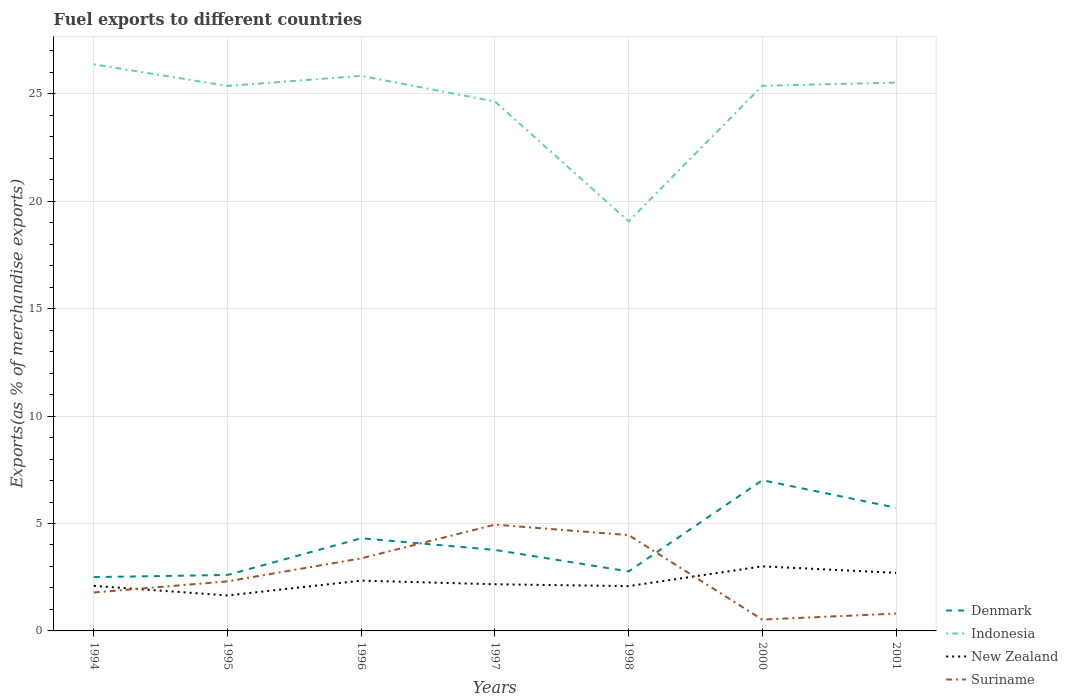How many different coloured lines are there?
Your response must be concise. 4. Is the number of lines equal to the number of legend labels?
Give a very brief answer. Yes. Across all years, what is the maximum percentage of exports to different countries in Suriname?
Offer a very short reply. 0.53. In which year was the percentage of exports to different countries in Indonesia maximum?
Your answer should be compact. 1998. What is the total percentage of exports to different countries in New Zealand in the graph?
Offer a very short reply. -0.66. What is the difference between the highest and the second highest percentage of exports to different countries in Denmark?
Keep it short and to the point. 4.51. What is the difference between the highest and the lowest percentage of exports to different countries in Denmark?
Make the answer very short. 3. How many years are there in the graph?
Offer a very short reply. 7. Are the values on the major ticks of Y-axis written in scientific E-notation?
Your answer should be compact. No. Does the graph contain any zero values?
Provide a short and direct response. No. Where does the legend appear in the graph?
Your answer should be very brief. Bottom right. How are the legend labels stacked?
Provide a succinct answer. Vertical. What is the title of the graph?
Your response must be concise. Fuel exports to different countries. What is the label or title of the X-axis?
Provide a short and direct response. Years. What is the label or title of the Y-axis?
Offer a terse response. Exports(as % of merchandise exports). What is the Exports(as % of merchandise exports) of Denmark in 1994?
Your answer should be compact. 2.5. What is the Exports(as % of merchandise exports) of Indonesia in 1994?
Make the answer very short. 26.37. What is the Exports(as % of merchandise exports) of New Zealand in 1994?
Give a very brief answer. 2.1. What is the Exports(as % of merchandise exports) in Suriname in 1994?
Ensure brevity in your answer.  1.79. What is the Exports(as % of merchandise exports) in Denmark in 1995?
Provide a short and direct response. 2.6. What is the Exports(as % of merchandise exports) of Indonesia in 1995?
Offer a terse response. 25.36. What is the Exports(as % of merchandise exports) of New Zealand in 1995?
Ensure brevity in your answer.  1.65. What is the Exports(as % of merchandise exports) of Suriname in 1995?
Provide a succinct answer. 2.31. What is the Exports(as % of merchandise exports) in Denmark in 1996?
Make the answer very short. 4.31. What is the Exports(as % of merchandise exports) of Indonesia in 1996?
Your answer should be very brief. 25.83. What is the Exports(as % of merchandise exports) of New Zealand in 1996?
Keep it short and to the point. 2.34. What is the Exports(as % of merchandise exports) in Suriname in 1996?
Keep it short and to the point. 3.38. What is the Exports(as % of merchandise exports) in Denmark in 1997?
Give a very brief answer. 3.77. What is the Exports(as % of merchandise exports) in Indonesia in 1997?
Ensure brevity in your answer.  24.64. What is the Exports(as % of merchandise exports) in New Zealand in 1997?
Make the answer very short. 2.17. What is the Exports(as % of merchandise exports) in Suriname in 1997?
Offer a terse response. 4.95. What is the Exports(as % of merchandise exports) in Denmark in 1998?
Your answer should be very brief. 2.77. What is the Exports(as % of merchandise exports) of Indonesia in 1998?
Give a very brief answer. 19.06. What is the Exports(as % of merchandise exports) in New Zealand in 1998?
Ensure brevity in your answer.  2.09. What is the Exports(as % of merchandise exports) of Suriname in 1998?
Your answer should be compact. 4.46. What is the Exports(as % of merchandise exports) in Denmark in 2000?
Give a very brief answer. 7.02. What is the Exports(as % of merchandise exports) in Indonesia in 2000?
Keep it short and to the point. 25.37. What is the Exports(as % of merchandise exports) of New Zealand in 2000?
Offer a terse response. 3. What is the Exports(as % of merchandise exports) of Suriname in 2000?
Your answer should be very brief. 0.53. What is the Exports(as % of merchandise exports) of Denmark in 2001?
Provide a succinct answer. 5.73. What is the Exports(as % of merchandise exports) in Indonesia in 2001?
Give a very brief answer. 25.52. What is the Exports(as % of merchandise exports) in New Zealand in 2001?
Keep it short and to the point. 2.7. What is the Exports(as % of merchandise exports) of Suriname in 2001?
Offer a terse response. 0.81. Across all years, what is the maximum Exports(as % of merchandise exports) of Denmark?
Keep it short and to the point. 7.02. Across all years, what is the maximum Exports(as % of merchandise exports) in Indonesia?
Provide a succinct answer. 26.37. Across all years, what is the maximum Exports(as % of merchandise exports) of New Zealand?
Your answer should be compact. 3. Across all years, what is the maximum Exports(as % of merchandise exports) of Suriname?
Your answer should be compact. 4.95. Across all years, what is the minimum Exports(as % of merchandise exports) of Denmark?
Your answer should be compact. 2.5. Across all years, what is the minimum Exports(as % of merchandise exports) in Indonesia?
Provide a short and direct response. 19.06. Across all years, what is the minimum Exports(as % of merchandise exports) of New Zealand?
Provide a short and direct response. 1.65. Across all years, what is the minimum Exports(as % of merchandise exports) in Suriname?
Provide a short and direct response. 0.53. What is the total Exports(as % of merchandise exports) of Denmark in the graph?
Give a very brief answer. 28.71. What is the total Exports(as % of merchandise exports) of Indonesia in the graph?
Give a very brief answer. 172.16. What is the total Exports(as % of merchandise exports) of New Zealand in the graph?
Provide a short and direct response. 16.05. What is the total Exports(as % of merchandise exports) of Suriname in the graph?
Make the answer very short. 18.21. What is the difference between the Exports(as % of merchandise exports) of Denmark in 1994 and that in 1995?
Give a very brief answer. -0.1. What is the difference between the Exports(as % of merchandise exports) in New Zealand in 1994 and that in 1995?
Ensure brevity in your answer.  0.44. What is the difference between the Exports(as % of merchandise exports) of Suriname in 1994 and that in 1995?
Provide a succinct answer. -0.52. What is the difference between the Exports(as % of merchandise exports) of Denmark in 1994 and that in 1996?
Offer a terse response. -1.81. What is the difference between the Exports(as % of merchandise exports) in Indonesia in 1994 and that in 1996?
Give a very brief answer. 0.54. What is the difference between the Exports(as % of merchandise exports) of New Zealand in 1994 and that in 1996?
Make the answer very short. -0.24. What is the difference between the Exports(as % of merchandise exports) in Suriname in 1994 and that in 1996?
Your answer should be compact. -1.59. What is the difference between the Exports(as % of merchandise exports) in Denmark in 1994 and that in 1997?
Keep it short and to the point. -1.27. What is the difference between the Exports(as % of merchandise exports) in Indonesia in 1994 and that in 1997?
Keep it short and to the point. 1.73. What is the difference between the Exports(as % of merchandise exports) of New Zealand in 1994 and that in 1997?
Make the answer very short. -0.08. What is the difference between the Exports(as % of merchandise exports) in Suriname in 1994 and that in 1997?
Provide a short and direct response. -3.16. What is the difference between the Exports(as % of merchandise exports) in Denmark in 1994 and that in 1998?
Ensure brevity in your answer.  -0.27. What is the difference between the Exports(as % of merchandise exports) in Indonesia in 1994 and that in 1998?
Give a very brief answer. 7.31. What is the difference between the Exports(as % of merchandise exports) of New Zealand in 1994 and that in 1998?
Offer a very short reply. 0.01. What is the difference between the Exports(as % of merchandise exports) in Suriname in 1994 and that in 1998?
Provide a short and direct response. -2.67. What is the difference between the Exports(as % of merchandise exports) in Denmark in 1994 and that in 2000?
Your answer should be compact. -4.51. What is the difference between the Exports(as % of merchandise exports) of Indonesia in 1994 and that in 2000?
Keep it short and to the point. 1. What is the difference between the Exports(as % of merchandise exports) in New Zealand in 1994 and that in 2000?
Keep it short and to the point. -0.91. What is the difference between the Exports(as % of merchandise exports) in Suriname in 1994 and that in 2000?
Your answer should be very brief. 1.26. What is the difference between the Exports(as % of merchandise exports) of Denmark in 1994 and that in 2001?
Provide a succinct answer. -3.23. What is the difference between the Exports(as % of merchandise exports) in Indonesia in 1994 and that in 2001?
Provide a short and direct response. 0.85. What is the difference between the Exports(as % of merchandise exports) of New Zealand in 1994 and that in 2001?
Your response must be concise. -0.61. What is the difference between the Exports(as % of merchandise exports) of Suriname in 1994 and that in 2001?
Your answer should be compact. 0.98. What is the difference between the Exports(as % of merchandise exports) of Denmark in 1995 and that in 1996?
Your answer should be very brief. -1.71. What is the difference between the Exports(as % of merchandise exports) in Indonesia in 1995 and that in 1996?
Your answer should be very brief. -0.47. What is the difference between the Exports(as % of merchandise exports) of New Zealand in 1995 and that in 1996?
Your answer should be compact. -0.69. What is the difference between the Exports(as % of merchandise exports) in Suriname in 1995 and that in 1996?
Offer a very short reply. -1.07. What is the difference between the Exports(as % of merchandise exports) in Denmark in 1995 and that in 1997?
Offer a terse response. -1.17. What is the difference between the Exports(as % of merchandise exports) in Indonesia in 1995 and that in 1997?
Keep it short and to the point. 0.72. What is the difference between the Exports(as % of merchandise exports) in New Zealand in 1995 and that in 1997?
Provide a short and direct response. -0.52. What is the difference between the Exports(as % of merchandise exports) of Suriname in 1995 and that in 1997?
Your answer should be very brief. -2.64. What is the difference between the Exports(as % of merchandise exports) of Denmark in 1995 and that in 1998?
Your response must be concise. -0.16. What is the difference between the Exports(as % of merchandise exports) in Indonesia in 1995 and that in 1998?
Your response must be concise. 6.3. What is the difference between the Exports(as % of merchandise exports) of New Zealand in 1995 and that in 1998?
Give a very brief answer. -0.43. What is the difference between the Exports(as % of merchandise exports) of Suriname in 1995 and that in 1998?
Keep it short and to the point. -2.15. What is the difference between the Exports(as % of merchandise exports) of Denmark in 1995 and that in 2000?
Keep it short and to the point. -4.41. What is the difference between the Exports(as % of merchandise exports) of Indonesia in 1995 and that in 2000?
Provide a succinct answer. -0.01. What is the difference between the Exports(as % of merchandise exports) in New Zealand in 1995 and that in 2000?
Ensure brevity in your answer.  -1.35. What is the difference between the Exports(as % of merchandise exports) of Suriname in 1995 and that in 2000?
Give a very brief answer. 1.78. What is the difference between the Exports(as % of merchandise exports) in Denmark in 1995 and that in 2001?
Keep it short and to the point. -3.13. What is the difference between the Exports(as % of merchandise exports) in Indonesia in 1995 and that in 2001?
Offer a terse response. -0.16. What is the difference between the Exports(as % of merchandise exports) of New Zealand in 1995 and that in 2001?
Provide a short and direct response. -1.05. What is the difference between the Exports(as % of merchandise exports) of Suriname in 1995 and that in 2001?
Make the answer very short. 1.5. What is the difference between the Exports(as % of merchandise exports) in Denmark in 1996 and that in 1997?
Ensure brevity in your answer.  0.54. What is the difference between the Exports(as % of merchandise exports) in Indonesia in 1996 and that in 1997?
Your response must be concise. 1.19. What is the difference between the Exports(as % of merchandise exports) in New Zealand in 1996 and that in 1997?
Offer a terse response. 0.17. What is the difference between the Exports(as % of merchandise exports) in Suriname in 1996 and that in 1997?
Provide a succinct answer. -1.57. What is the difference between the Exports(as % of merchandise exports) in Denmark in 1996 and that in 1998?
Provide a succinct answer. 1.54. What is the difference between the Exports(as % of merchandise exports) of Indonesia in 1996 and that in 1998?
Ensure brevity in your answer.  6.77. What is the difference between the Exports(as % of merchandise exports) in New Zealand in 1996 and that in 1998?
Provide a short and direct response. 0.25. What is the difference between the Exports(as % of merchandise exports) of Suriname in 1996 and that in 1998?
Offer a very short reply. -1.08. What is the difference between the Exports(as % of merchandise exports) of Denmark in 1996 and that in 2000?
Keep it short and to the point. -2.7. What is the difference between the Exports(as % of merchandise exports) of Indonesia in 1996 and that in 2000?
Provide a short and direct response. 0.46. What is the difference between the Exports(as % of merchandise exports) in New Zealand in 1996 and that in 2000?
Offer a terse response. -0.66. What is the difference between the Exports(as % of merchandise exports) of Suriname in 1996 and that in 2000?
Your response must be concise. 2.85. What is the difference between the Exports(as % of merchandise exports) of Denmark in 1996 and that in 2001?
Provide a short and direct response. -1.42. What is the difference between the Exports(as % of merchandise exports) of Indonesia in 1996 and that in 2001?
Offer a very short reply. 0.31. What is the difference between the Exports(as % of merchandise exports) of New Zealand in 1996 and that in 2001?
Ensure brevity in your answer.  -0.36. What is the difference between the Exports(as % of merchandise exports) in Suriname in 1996 and that in 2001?
Offer a terse response. 2.57. What is the difference between the Exports(as % of merchandise exports) in Denmark in 1997 and that in 1998?
Your answer should be very brief. 1. What is the difference between the Exports(as % of merchandise exports) in Indonesia in 1997 and that in 1998?
Give a very brief answer. 5.58. What is the difference between the Exports(as % of merchandise exports) of New Zealand in 1997 and that in 1998?
Offer a terse response. 0.09. What is the difference between the Exports(as % of merchandise exports) in Suriname in 1997 and that in 1998?
Your response must be concise. 0.49. What is the difference between the Exports(as % of merchandise exports) of Denmark in 1997 and that in 2000?
Offer a very short reply. -3.25. What is the difference between the Exports(as % of merchandise exports) in Indonesia in 1997 and that in 2000?
Keep it short and to the point. -0.73. What is the difference between the Exports(as % of merchandise exports) of New Zealand in 1997 and that in 2000?
Your answer should be compact. -0.83. What is the difference between the Exports(as % of merchandise exports) of Suriname in 1997 and that in 2000?
Give a very brief answer. 4.42. What is the difference between the Exports(as % of merchandise exports) in Denmark in 1997 and that in 2001?
Provide a short and direct response. -1.96. What is the difference between the Exports(as % of merchandise exports) in Indonesia in 1997 and that in 2001?
Provide a short and direct response. -0.88. What is the difference between the Exports(as % of merchandise exports) of New Zealand in 1997 and that in 2001?
Make the answer very short. -0.53. What is the difference between the Exports(as % of merchandise exports) in Suriname in 1997 and that in 2001?
Your response must be concise. 4.14. What is the difference between the Exports(as % of merchandise exports) of Denmark in 1998 and that in 2000?
Your answer should be very brief. -4.25. What is the difference between the Exports(as % of merchandise exports) of Indonesia in 1998 and that in 2000?
Your answer should be compact. -6.31. What is the difference between the Exports(as % of merchandise exports) in New Zealand in 1998 and that in 2000?
Make the answer very short. -0.92. What is the difference between the Exports(as % of merchandise exports) of Suriname in 1998 and that in 2000?
Offer a very short reply. 3.93. What is the difference between the Exports(as % of merchandise exports) in Denmark in 1998 and that in 2001?
Keep it short and to the point. -2.96. What is the difference between the Exports(as % of merchandise exports) of Indonesia in 1998 and that in 2001?
Your response must be concise. -6.46. What is the difference between the Exports(as % of merchandise exports) in New Zealand in 1998 and that in 2001?
Provide a short and direct response. -0.62. What is the difference between the Exports(as % of merchandise exports) of Suriname in 1998 and that in 2001?
Your response must be concise. 3.65. What is the difference between the Exports(as % of merchandise exports) of Denmark in 2000 and that in 2001?
Give a very brief answer. 1.28. What is the difference between the Exports(as % of merchandise exports) of Indonesia in 2000 and that in 2001?
Ensure brevity in your answer.  -0.15. What is the difference between the Exports(as % of merchandise exports) in New Zealand in 2000 and that in 2001?
Keep it short and to the point. 0.3. What is the difference between the Exports(as % of merchandise exports) in Suriname in 2000 and that in 2001?
Your response must be concise. -0.28. What is the difference between the Exports(as % of merchandise exports) of Denmark in 1994 and the Exports(as % of merchandise exports) of Indonesia in 1995?
Provide a succinct answer. -22.86. What is the difference between the Exports(as % of merchandise exports) of Denmark in 1994 and the Exports(as % of merchandise exports) of New Zealand in 1995?
Your answer should be very brief. 0.85. What is the difference between the Exports(as % of merchandise exports) of Denmark in 1994 and the Exports(as % of merchandise exports) of Suriname in 1995?
Make the answer very short. 0.2. What is the difference between the Exports(as % of merchandise exports) of Indonesia in 1994 and the Exports(as % of merchandise exports) of New Zealand in 1995?
Give a very brief answer. 24.72. What is the difference between the Exports(as % of merchandise exports) of Indonesia in 1994 and the Exports(as % of merchandise exports) of Suriname in 1995?
Your answer should be compact. 24.06. What is the difference between the Exports(as % of merchandise exports) of New Zealand in 1994 and the Exports(as % of merchandise exports) of Suriname in 1995?
Keep it short and to the point. -0.21. What is the difference between the Exports(as % of merchandise exports) of Denmark in 1994 and the Exports(as % of merchandise exports) of Indonesia in 1996?
Your response must be concise. -23.33. What is the difference between the Exports(as % of merchandise exports) in Denmark in 1994 and the Exports(as % of merchandise exports) in New Zealand in 1996?
Provide a short and direct response. 0.16. What is the difference between the Exports(as % of merchandise exports) in Denmark in 1994 and the Exports(as % of merchandise exports) in Suriname in 1996?
Make the answer very short. -0.87. What is the difference between the Exports(as % of merchandise exports) of Indonesia in 1994 and the Exports(as % of merchandise exports) of New Zealand in 1996?
Provide a short and direct response. 24.03. What is the difference between the Exports(as % of merchandise exports) in Indonesia in 1994 and the Exports(as % of merchandise exports) in Suriname in 1996?
Make the answer very short. 22.99. What is the difference between the Exports(as % of merchandise exports) in New Zealand in 1994 and the Exports(as % of merchandise exports) in Suriname in 1996?
Make the answer very short. -1.28. What is the difference between the Exports(as % of merchandise exports) in Denmark in 1994 and the Exports(as % of merchandise exports) in Indonesia in 1997?
Your response must be concise. -22.14. What is the difference between the Exports(as % of merchandise exports) in Denmark in 1994 and the Exports(as % of merchandise exports) in New Zealand in 1997?
Your answer should be compact. 0.33. What is the difference between the Exports(as % of merchandise exports) in Denmark in 1994 and the Exports(as % of merchandise exports) in Suriname in 1997?
Your answer should be compact. -2.44. What is the difference between the Exports(as % of merchandise exports) of Indonesia in 1994 and the Exports(as % of merchandise exports) of New Zealand in 1997?
Offer a terse response. 24.2. What is the difference between the Exports(as % of merchandise exports) in Indonesia in 1994 and the Exports(as % of merchandise exports) in Suriname in 1997?
Offer a terse response. 21.42. What is the difference between the Exports(as % of merchandise exports) in New Zealand in 1994 and the Exports(as % of merchandise exports) in Suriname in 1997?
Your response must be concise. -2.85. What is the difference between the Exports(as % of merchandise exports) in Denmark in 1994 and the Exports(as % of merchandise exports) in Indonesia in 1998?
Your answer should be very brief. -16.56. What is the difference between the Exports(as % of merchandise exports) in Denmark in 1994 and the Exports(as % of merchandise exports) in New Zealand in 1998?
Provide a short and direct response. 0.42. What is the difference between the Exports(as % of merchandise exports) in Denmark in 1994 and the Exports(as % of merchandise exports) in Suriname in 1998?
Give a very brief answer. -1.96. What is the difference between the Exports(as % of merchandise exports) of Indonesia in 1994 and the Exports(as % of merchandise exports) of New Zealand in 1998?
Give a very brief answer. 24.28. What is the difference between the Exports(as % of merchandise exports) in Indonesia in 1994 and the Exports(as % of merchandise exports) in Suriname in 1998?
Your response must be concise. 21.91. What is the difference between the Exports(as % of merchandise exports) in New Zealand in 1994 and the Exports(as % of merchandise exports) in Suriname in 1998?
Your answer should be compact. -2.36. What is the difference between the Exports(as % of merchandise exports) in Denmark in 1994 and the Exports(as % of merchandise exports) in Indonesia in 2000?
Provide a short and direct response. -22.87. What is the difference between the Exports(as % of merchandise exports) in Denmark in 1994 and the Exports(as % of merchandise exports) in New Zealand in 2000?
Ensure brevity in your answer.  -0.5. What is the difference between the Exports(as % of merchandise exports) of Denmark in 1994 and the Exports(as % of merchandise exports) of Suriname in 2000?
Make the answer very short. 1.98. What is the difference between the Exports(as % of merchandise exports) of Indonesia in 1994 and the Exports(as % of merchandise exports) of New Zealand in 2000?
Offer a terse response. 23.36. What is the difference between the Exports(as % of merchandise exports) in Indonesia in 1994 and the Exports(as % of merchandise exports) in Suriname in 2000?
Give a very brief answer. 25.84. What is the difference between the Exports(as % of merchandise exports) in New Zealand in 1994 and the Exports(as % of merchandise exports) in Suriname in 2000?
Make the answer very short. 1.57. What is the difference between the Exports(as % of merchandise exports) of Denmark in 1994 and the Exports(as % of merchandise exports) of Indonesia in 2001?
Offer a very short reply. -23.02. What is the difference between the Exports(as % of merchandise exports) in Denmark in 1994 and the Exports(as % of merchandise exports) in New Zealand in 2001?
Your response must be concise. -0.2. What is the difference between the Exports(as % of merchandise exports) of Denmark in 1994 and the Exports(as % of merchandise exports) of Suriname in 2001?
Keep it short and to the point. 1.7. What is the difference between the Exports(as % of merchandise exports) in Indonesia in 1994 and the Exports(as % of merchandise exports) in New Zealand in 2001?
Ensure brevity in your answer.  23.67. What is the difference between the Exports(as % of merchandise exports) of Indonesia in 1994 and the Exports(as % of merchandise exports) of Suriname in 2001?
Your answer should be compact. 25.56. What is the difference between the Exports(as % of merchandise exports) in New Zealand in 1994 and the Exports(as % of merchandise exports) in Suriname in 2001?
Provide a short and direct response. 1.29. What is the difference between the Exports(as % of merchandise exports) in Denmark in 1995 and the Exports(as % of merchandise exports) in Indonesia in 1996?
Your answer should be compact. -23.23. What is the difference between the Exports(as % of merchandise exports) in Denmark in 1995 and the Exports(as % of merchandise exports) in New Zealand in 1996?
Your answer should be very brief. 0.26. What is the difference between the Exports(as % of merchandise exports) of Denmark in 1995 and the Exports(as % of merchandise exports) of Suriname in 1996?
Your response must be concise. -0.77. What is the difference between the Exports(as % of merchandise exports) of Indonesia in 1995 and the Exports(as % of merchandise exports) of New Zealand in 1996?
Make the answer very short. 23.02. What is the difference between the Exports(as % of merchandise exports) in Indonesia in 1995 and the Exports(as % of merchandise exports) in Suriname in 1996?
Provide a short and direct response. 21.99. What is the difference between the Exports(as % of merchandise exports) in New Zealand in 1995 and the Exports(as % of merchandise exports) in Suriname in 1996?
Make the answer very short. -1.73. What is the difference between the Exports(as % of merchandise exports) in Denmark in 1995 and the Exports(as % of merchandise exports) in Indonesia in 1997?
Keep it short and to the point. -22.04. What is the difference between the Exports(as % of merchandise exports) of Denmark in 1995 and the Exports(as % of merchandise exports) of New Zealand in 1997?
Keep it short and to the point. 0.43. What is the difference between the Exports(as % of merchandise exports) in Denmark in 1995 and the Exports(as % of merchandise exports) in Suriname in 1997?
Give a very brief answer. -2.34. What is the difference between the Exports(as % of merchandise exports) in Indonesia in 1995 and the Exports(as % of merchandise exports) in New Zealand in 1997?
Give a very brief answer. 23.19. What is the difference between the Exports(as % of merchandise exports) of Indonesia in 1995 and the Exports(as % of merchandise exports) of Suriname in 1997?
Offer a terse response. 20.42. What is the difference between the Exports(as % of merchandise exports) of New Zealand in 1995 and the Exports(as % of merchandise exports) of Suriname in 1997?
Offer a terse response. -3.29. What is the difference between the Exports(as % of merchandise exports) of Denmark in 1995 and the Exports(as % of merchandise exports) of Indonesia in 1998?
Offer a terse response. -16.46. What is the difference between the Exports(as % of merchandise exports) in Denmark in 1995 and the Exports(as % of merchandise exports) in New Zealand in 1998?
Your answer should be very brief. 0.52. What is the difference between the Exports(as % of merchandise exports) in Denmark in 1995 and the Exports(as % of merchandise exports) in Suriname in 1998?
Your answer should be very brief. -1.85. What is the difference between the Exports(as % of merchandise exports) of Indonesia in 1995 and the Exports(as % of merchandise exports) of New Zealand in 1998?
Offer a terse response. 23.28. What is the difference between the Exports(as % of merchandise exports) of Indonesia in 1995 and the Exports(as % of merchandise exports) of Suriname in 1998?
Offer a very short reply. 20.9. What is the difference between the Exports(as % of merchandise exports) of New Zealand in 1995 and the Exports(as % of merchandise exports) of Suriname in 1998?
Offer a very short reply. -2.81. What is the difference between the Exports(as % of merchandise exports) of Denmark in 1995 and the Exports(as % of merchandise exports) of Indonesia in 2000?
Offer a terse response. -22.77. What is the difference between the Exports(as % of merchandise exports) in Denmark in 1995 and the Exports(as % of merchandise exports) in New Zealand in 2000?
Give a very brief answer. -0.4. What is the difference between the Exports(as % of merchandise exports) of Denmark in 1995 and the Exports(as % of merchandise exports) of Suriname in 2000?
Ensure brevity in your answer.  2.08. What is the difference between the Exports(as % of merchandise exports) of Indonesia in 1995 and the Exports(as % of merchandise exports) of New Zealand in 2000?
Give a very brief answer. 22.36. What is the difference between the Exports(as % of merchandise exports) of Indonesia in 1995 and the Exports(as % of merchandise exports) of Suriname in 2000?
Make the answer very short. 24.84. What is the difference between the Exports(as % of merchandise exports) in New Zealand in 1995 and the Exports(as % of merchandise exports) in Suriname in 2000?
Keep it short and to the point. 1.12. What is the difference between the Exports(as % of merchandise exports) in Denmark in 1995 and the Exports(as % of merchandise exports) in Indonesia in 2001?
Your response must be concise. -22.92. What is the difference between the Exports(as % of merchandise exports) in Denmark in 1995 and the Exports(as % of merchandise exports) in New Zealand in 2001?
Ensure brevity in your answer.  -0.1. What is the difference between the Exports(as % of merchandise exports) in Denmark in 1995 and the Exports(as % of merchandise exports) in Suriname in 2001?
Give a very brief answer. 1.8. What is the difference between the Exports(as % of merchandise exports) in Indonesia in 1995 and the Exports(as % of merchandise exports) in New Zealand in 2001?
Your answer should be very brief. 22.66. What is the difference between the Exports(as % of merchandise exports) in Indonesia in 1995 and the Exports(as % of merchandise exports) in Suriname in 2001?
Your answer should be very brief. 24.56. What is the difference between the Exports(as % of merchandise exports) in New Zealand in 1995 and the Exports(as % of merchandise exports) in Suriname in 2001?
Offer a very short reply. 0.84. What is the difference between the Exports(as % of merchandise exports) in Denmark in 1996 and the Exports(as % of merchandise exports) in Indonesia in 1997?
Ensure brevity in your answer.  -20.33. What is the difference between the Exports(as % of merchandise exports) in Denmark in 1996 and the Exports(as % of merchandise exports) in New Zealand in 1997?
Keep it short and to the point. 2.14. What is the difference between the Exports(as % of merchandise exports) of Denmark in 1996 and the Exports(as % of merchandise exports) of Suriname in 1997?
Offer a very short reply. -0.63. What is the difference between the Exports(as % of merchandise exports) in Indonesia in 1996 and the Exports(as % of merchandise exports) in New Zealand in 1997?
Ensure brevity in your answer.  23.66. What is the difference between the Exports(as % of merchandise exports) of Indonesia in 1996 and the Exports(as % of merchandise exports) of Suriname in 1997?
Ensure brevity in your answer.  20.89. What is the difference between the Exports(as % of merchandise exports) of New Zealand in 1996 and the Exports(as % of merchandise exports) of Suriname in 1997?
Your response must be concise. -2.61. What is the difference between the Exports(as % of merchandise exports) in Denmark in 1996 and the Exports(as % of merchandise exports) in Indonesia in 1998?
Keep it short and to the point. -14.75. What is the difference between the Exports(as % of merchandise exports) of Denmark in 1996 and the Exports(as % of merchandise exports) of New Zealand in 1998?
Ensure brevity in your answer.  2.23. What is the difference between the Exports(as % of merchandise exports) in Denmark in 1996 and the Exports(as % of merchandise exports) in Suriname in 1998?
Your answer should be very brief. -0.15. What is the difference between the Exports(as % of merchandise exports) in Indonesia in 1996 and the Exports(as % of merchandise exports) in New Zealand in 1998?
Give a very brief answer. 23.75. What is the difference between the Exports(as % of merchandise exports) of Indonesia in 1996 and the Exports(as % of merchandise exports) of Suriname in 1998?
Your answer should be compact. 21.37. What is the difference between the Exports(as % of merchandise exports) in New Zealand in 1996 and the Exports(as % of merchandise exports) in Suriname in 1998?
Offer a terse response. -2.12. What is the difference between the Exports(as % of merchandise exports) in Denmark in 1996 and the Exports(as % of merchandise exports) in Indonesia in 2000?
Make the answer very short. -21.06. What is the difference between the Exports(as % of merchandise exports) in Denmark in 1996 and the Exports(as % of merchandise exports) in New Zealand in 2000?
Offer a very short reply. 1.31. What is the difference between the Exports(as % of merchandise exports) of Denmark in 1996 and the Exports(as % of merchandise exports) of Suriname in 2000?
Provide a succinct answer. 3.78. What is the difference between the Exports(as % of merchandise exports) in Indonesia in 1996 and the Exports(as % of merchandise exports) in New Zealand in 2000?
Offer a very short reply. 22.83. What is the difference between the Exports(as % of merchandise exports) of Indonesia in 1996 and the Exports(as % of merchandise exports) of Suriname in 2000?
Keep it short and to the point. 25.3. What is the difference between the Exports(as % of merchandise exports) in New Zealand in 1996 and the Exports(as % of merchandise exports) in Suriname in 2000?
Offer a very short reply. 1.81. What is the difference between the Exports(as % of merchandise exports) of Denmark in 1996 and the Exports(as % of merchandise exports) of Indonesia in 2001?
Offer a very short reply. -21.21. What is the difference between the Exports(as % of merchandise exports) in Denmark in 1996 and the Exports(as % of merchandise exports) in New Zealand in 2001?
Provide a short and direct response. 1.61. What is the difference between the Exports(as % of merchandise exports) in Denmark in 1996 and the Exports(as % of merchandise exports) in Suriname in 2001?
Make the answer very short. 3.51. What is the difference between the Exports(as % of merchandise exports) in Indonesia in 1996 and the Exports(as % of merchandise exports) in New Zealand in 2001?
Ensure brevity in your answer.  23.13. What is the difference between the Exports(as % of merchandise exports) of Indonesia in 1996 and the Exports(as % of merchandise exports) of Suriname in 2001?
Your answer should be compact. 25.03. What is the difference between the Exports(as % of merchandise exports) in New Zealand in 1996 and the Exports(as % of merchandise exports) in Suriname in 2001?
Your response must be concise. 1.53. What is the difference between the Exports(as % of merchandise exports) of Denmark in 1997 and the Exports(as % of merchandise exports) of Indonesia in 1998?
Offer a very short reply. -15.29. What is the difference between the Exports(as % of merchandise exports) in Denmark in 1997 and the Exports(as % of merchandise exports) in New Zealand in 1998?
Ensure brevity in your answer.  1.68. What is the difference between the Exports(as % of merchandise exports) of Denmark in 1997 and the Exports(as % of merchandise exports) of Suriname in 1998?
Provide a short and direct response. -0.69. What is the difference between the Exports(as % of merchandise exports) in Indonesia in 1997 and the Exports(as % of merchandise exports) in New Zealand in 1998?
Keep it short and to the point. 22.56. What is the difference between the Exports(as % of merchandise exports) of Indonesia in 1997 and the Exports(as % of merchandise exports) of Suriname in 1998?
Offer a terse response. 20.18. What is the difference between the Exports(as % of merchandise exports) in New Zealand in 1997 and the Exports(as % of merchandise exports) in Suriname in 1998?
Provide a short and direct response. -2.29. What is the difference between the Exports(as % of merchandise exports) of Denmark in 1997 and the Exports(as % of merchandise exports) of Indonesia in 2000?
Your answer should be compact. -21.6. What is the difference between the Exports(as % of merchandise exports) in Denmark in 1997 and the Exports(as % of merchandise exports) in New Zealand in 2000?
Your answer should be compact. 0.77. What is the difference between the Exports(as % of merchandise exports) of Denmark in 1997 and the Exports(as % of merchandise exports) of Suriname in 2000?
Your answer should be compact. 3.24. What is the difference between the Exports(as % of merchandise exports) in Indonesia in 1997 and the Exports(as % of merchandise exports) in New Zealand in 2000?
Ensure brevity in your answer.  21.64. What is the difference between the Exports(as % of merchandise exports) in Indonesia in 1997 and the Exports(as % of merchandise exports) in Suriname in 2000?
Keep it short and to the point. 24.11. What is the difference between the Exports(as % of merchandise exports) of New Zealand in 1997 and the Exports(as % of merchandise exports) of Suriname in 2000?
Your response must be concise. 1.64. What is the difference between the Exports(as % of merchandise exports) in Denmark in 1997 and the Exports(as % of merchandise exports) in Indonesia in 2001?
Provide a succinct answer. -21.75. What is the difference between the Exports(as % of merchandise exports) in Denmark in 1997 and the Exports(as % of merchandise exports) in New Zealand in 2001?
Your response must be concise. 1.07. What is the difference between the Exports(as % of merchandise exports) in Denmark in 1997 and the Exports(as % of merchandise exports) in Suriname in 2001?
Make the answer very short. 2.96. What is the difference between the Exports(as % of merchandise exports) of Indonesia in 1997 and the Exports(as % of merchandise exports) of New Zealand in 2001?
Provide a short and direct response. 21.94. What is the difference between the Exports(as % of merchandise exports) of Indonesia in 1997 and the Exports(as % of merchandise exports) of Suriname in 2001?
Your response must be concise. 23.83. What is the difference between the Exports(as % of merchandise exports) of New Zealand in 1997 and the Exports(as % of merchandise exports) of Suriname in 2001?
Your response must be concise. 1.37. What is the difference between the Exports(as % of merchandise exports) of Denmark in 1998 and the Exports(as % of merchandise exports) of Indonesia in 2000?
Provide a short and direct response. -22.6. What is the difference between the Exports(as % of merchandise exports) in Denmark in 1998 and the Exports(as % of merchandise exports) in New Zealand in 2000?
Provide a short and direct response. -0.24. What is the difference between the Exports(as % of merchandise exports) in Denmark in 1998 and the Exports(as % of merchandise exports) in Suriname in 2000?
Make the answer very short. 2.24. What is the difference between the Exports(as % of merchandise exports) in Indonesia in 1998 and the Exports(as % of merchandise exports) in New Zealand in 2000?
Offer a very short reply. 16.06. What is the difference between the Exports(as % of merchandise exports) in Indonesia in 1998 and the Exports(as % of merchandise exports) in Suriname in 2000?
Keep it short and to the point. 18.54. What is the difference between the Exports(as % of merchandise exports) of New Zealand in 1998 and the Exports(as % of merchandise exports) of Suriname in 2000?
Provide a short and direct response. 1.56. What is the difference between the Exports(as % of merchandise exports) in Denmark in 1998 and the Exports(as % of merchandise exports) in Indonesia in 2001?
Your answer should be compact. -22.75. What is the difference between the Exports(as % of merchandise exports) in Denmark in 1998 and the Exports(as % of merchandise exports) in New Zealand in 2001?
Provide a succinct answer. 0.07. What is the difference between the Exports(as % of merchandise exports) in Denmark in 1998 and the Exports(as % of merchandise exports) in Suriname in 2001?
Ensure brevity in your answer.  1.96. What is the difference between the Exports(as % of merchandise exports) of Indonesia in 1998 and the Exports(as % of merchandise exports) of New Zealand in 2001?
Provide a short and direct response. 16.36. What is the difference between the Exports(as % of merchandise exports) in Indonesia in 1998 and the Exports(as % of merchandise exports) in Suriname in 2001?
Provide a succinct answer. 18.26. What is the difference between the Exports(as % of merchandise exports) in New Zealand in 1998 and the Exports(as % of merchandise exports) in Suriname in 2001?
Provide a short and direct response. 1.28. What is the difference between the Exports(as % of merchandise exports) in Denmark in 2000 and the Exports(as % of merchandise exports) in Indonesia in 2001?
Provide a succinct answer. -18.5. What is the difference between the Exports(as % of merchandise exports) of Denmark in 2000 and the Exports(as % of merchandise exports) of New Zealand in 2001?
Give a very brief answer. 4.31. What is the difference between the Exports(as % of merchandise exports) of Denmark in 2000 and the Exports(as % of merchandise exports) of Suriname in 2001?
Your response must be concise. 6.21. What is the difference between the Exports(as % of merchandise exports) of Indonesia in 2000 and the Exports(as % of merchandise exports) of New Zealand in 2001?
Provide a succinct answer. 22.67. What is the difference between the Exports(as % of merchandise exports) in Indonesia in 2000 and the Exports(as % of merchandise exports) in Suriname in 2001?
Your answer should be compact. 24.56. What is the difference between the Exports(as % of merchandise exports) of New Zealand in 2000 and the Exports(as % of merchandise exports) of Suriname in 2001?
Make the answer very short. 2.2. What is the average Exports(as % of merchandise exports) in Denmark per year?
Keep it short and to the point. 4.1. What is the average Exports(as % of merchandise exports) in Indonesia per year?
Keep it short and to the point. 24.59. What is the average Exports(as % of merchandise exports) in New Zealand per year?
Your answer should be compact. 2.29. What is the average Exports(as % of merchandise exports) in Suriname per year?
Make the answer very short. 2.6. In the year 1994, what is the difference between the Exports(as % of merchandise exports) of Denmark and Exports(as % of merchandise exports) of Indonesia?
Keep it short and to the point. -23.87. In the year 1994, what is the difference between the Exports(as % of merchandise exports) in Denmark and Exports(as % of merchandise exports) in New Zealand?
Your answer should be very brief. 0.41. In the year 1994, what is the difference between the Exports(as % of merchandise exports) in Denmark and Exports(as % of merchandise exports) in Suriname?
Provide a short and direct response. 0.71. In the year 1994, what is the difference between the Exports(as % of merchandise exports) in Indonesia and Exports(as % of merchandise exports) in New Zealand?
Make the answer very short. 24.27. In the year 1994, what is the difference between the Exports(as % of merchandise exports) in Indonesia and Exports(as % of merchandise exports) in Suriname?
Keep it short and to the point. 24.58. In the year 1994, what is the difference between the Exports(as % of merchandise exports) in New Zealand and Exports(as % of merchandise exports) in Suriname?
Keep it short and to the point. 0.31. In the year 1995, what is the difference between the Exports(as % of merchandise exports) of Denmark and Exports(as % of merchandise exports) of Indonesia?
Make the answer very short. -22.76. In the year 1995, what is the difference between the Exports(as % of merchandise exports) in Denmark and Exports(as % of merchandise exports) in New Zealand?
Make the answer very short. 0.95. In the year 1995, what is the difference between the Exports(as % of merchandise exports) of Denmark and Exports(as % of merchandise exports) of Suriname?
Give a very brief answer. 0.3. In the year 1995, what is the difference between the Exports(as % of merchandise exports) of Indonesia and Exports(as % of merchandise exports) of New Zealand?
Your answer should be compact. 23.71. In the year 1995, what is the difference between the Exports(as % of merchandise exports) of Indonesia and Exports(as % of merchandise exports) of Suriname?
Make the answer very short. 23.06. In the year 1995, what is the difference between the Exports(as % of merchandise exports) of New Zealand and Exports(as % of merchandise exports) of Suriname?
Make the answer very short. -0.65. In the year 1996, what is the difference between the Exports(as % of merchandise exports) in Denmark and Exports(as % of merchandise exports) in Indonesia?
Give a very brief answer. -21.52. In the year 1996, what is the difference between the Exports(as % of merchandise exports) of Denmark and Exports(as % of merchandise exports) of New Zealand?
Offer a terse response. 1.97. In the year 1996, what is the difference between the Exports(as % of merchandise exports) of Denmark and Exports(as % of merchandise exports) of Suriname?
Provide a short and direct response. 0.94. In the year 1996, what is the difference between the Exports(as % of merchandise exports) of Indonesia and Exports(as % of merchandise exports) of New Zealand?
Give a very brief answer. 23.49. In the year 1996, what is the difference between the Exports(as % of merchandise exports) of Indonesia and Exports(as % of merchandise exports) of Suriname?
Your answer should be compact. 22.45. In the year 1996, what is the difference between the Exports(as % of merchandise exports) in New Zealand and Exports(as % of merchandise exports) in Suriname?
Provide a succinct answer. -1.04. In the year 1997, what is the difference between the Exports(as % of merchandise exports) of Denmark and Exports(as % of merchandise exports) of Indonesia?
Offer a terse response. -20.87. In the year 1997, what is the difference between the Exports(as % of merchandise exports) in Denmark and Exports(as % of merchandise exports) in New Zealand?
Your answer should be very brief. 1.6. In the year 1997, what is the difference between the Exports(as % of merchandise exports) in Denmark and Exports(as % of merchandise exports) in Suriname?
Offer a very short reply. -1.18. In the year 1997, what is the difference between the Exports(as % of merchandise exports) in Indonesia and Exports(as % of merchandise exports) in New Zealand?
Your response must be concise. 22.47. In the year 1997, what is the difference between the Exports(as % of merchandise exports) in Indonesia and Exports(as % of merchandise exports) in Suriname?
Provide a short and direct response. 19.69. In the year 1997, what is the difference between the Exports(as % of merchandise exports) of New Zealand and Exports(as % of merchandise exports) of Suriname?
Your answer should be compact. -2.77. In the year 1998, what is the difference between the Exports(as % of merchandise exports) of Denmark and Exports(as % of merchandise exports) of Indonesia?
Give a very brief answer. -16.3. In the year 1998, what is the difference between the Exports(as % of merchandise exports) in Denmark and Exports(as % of merchandise exports) in New Zealand?
Make the answer very short. 0.68. In the year 1998, what is the difference between the Exports(as % of merchandise exports) of Denmark and Exports(as % of merchandise exports) of Suriname?
Ensure brevity in your answer.  -1.69. In the year 1998, what is the difference between the Exports(as % of merchandise exports) in Indonesia and Exports(as % of merchandise exports) in New Zealand?
Provide a short and direct response. 16.98. In the year 1998, what is the difference between the Exports(as % of merchandise exports) of Indonesia and Exports(as % of merchandise exports) of Suriname?
Keep it short and to the point. 14.61. In the year 1998, what is the difference between the Exports(as % of merchandise exports) of New Zealand and Exports(as % of merchandise exports) of Suriname?
Your response must be concise. -2.37. In the year 2000, what is the difference between the Exports(as % of merchandise exports) of Denmark and Exports(as % of merchandise exports) of Indonesia?
Your response must be concise. -18.36. In the year 2000, what is the difference between the Exports(as % of merchandise exports) of Denmark and Exports(as % of merchandise exports) of New Zealand?
Offer a terse response. 4.01. In the year 2000, what is the difference between the Exports(as % of merchandise exports) in Denmark and Exports(as % of merchandise exports) in Suriname?
Offer a very short reply. 6.49. In the year 2000, what is the difference between the Exports(as % of merchandise exports) of Indonesia and Exports(as % of merchandise exports) of New Zealand?
Provide a succinct answer. 22.37. In the year 2000, what is the difference between the Exports(as % of merchandise exports) of Indonesia and Exports(as % of merchandise exports) of Suriname?
Offer a terse response. 24.84. In the year 2000, what is the difference between the Exports(as % of merchandise exports) in New Zealand and Exports(as % of merchandise exports) in Suriname?
Your answer should be compact. 2.48. In the year 2001, what is the difference between the Exports(as % of merchandise exports) in Denmark and Exports(as % of merchandise exports) in Indonesia?
Your response must be concise. -19.79. In the year 2001, what is the difference between the Exports(as % of merchandise exports) of Denmark and Exports(as % of merchandise exports) of New Zealand?
Provide a short and direct response. 3.03. In the year 2001, what is the difference between the Exports(as % of merchandise exports) in Denmark and Exports(as % of merchandise exports) in Suriname?
Give a very brief answer. 4.93. In the year 2001, what is the difference between the Exports(as % of merchandise exports) of Indonesia and Exports(as % of merchandise exports) of New Zealand?
Make the answer very short. 22.82. In the year 2001, what is the difference between the Exports(as % of merchandise exports) in Indonesia and Exports(as % of merchandise exports) in Suriname?
Your answer should be very brief. 24.71. In the year 2001, what is the difference between the Exports(as % of merchandise exports) in New Zealand and Exports(as % of merchandise exports) in Suriname?
Give a very brief answer. 1.9. What is the ratio of the Exports(as % of merchandise exports) in Denmark in 1994 to that in 1995?
Give a very brief answer. 0.96. What is the ratio of the Exports(as % of merchandise exports) in Indonesia in 1994 to that in 1995?
Offer a terse response. 1.04. What is the ratio of the Exports(as % of merchandise exports) of New Zealand in 1994 to that in 1995?
Your response must be concise. 1.27. What is the ratio of the Exports(as % of merchandise exports) of Suriname in 1994 to that in 1995?
Give a very brief answer. 0.78. What is the ratio of the Exports(as % of merchandise exports) in Denmark in 1994 to that in 1996?
Offer a very short reply. 0.58. What is the ratio of the Exports(as % of merchandise exports) in Indonesia in 1994 to that in 1996?
Your response must be concise. 1.02. What is the ratio of the Exports(as % of merchandise exports) in New Zealand in 1994 to that in 1996?
Your response must be concise. 0.9. What is the ratio of the Exports(as % of merchandise exports) of Suriname in 1994 to that in 1996?
Provide a short and direct response. 0.53. What is the ratio of the Exports(as % of merchandise exports) in Denmark in 1994 to that in 1997?
Your response must be concise. 0.66. What is the ratio of the Exports(as % of merchandise exports) of Indonesia in 1994 to that in 1997?
Your response must be concise. 1.07. What is the ratio of the Exports(as % of merchandise exports) of New Zealand in 1994 to that in 1997?
Offer a very short reply. 0.96. What is the ratio of the Exports(as % of merchandise exports) in Suriname in 1994 to that in 1997?
Offer a very short reply. 0.36. What is the ratio of the Exports(as % of merchandise exports) in Denmark in 1994 to that in 1998?
Your response must be concise. 0.9. What is the ratio of the Exports(as % of merchandise exports) in Indonesia in 1994 to that in 1998?
Keep it short and to the point. 1.38. What is the ratio of the Exports(as % of merchandise exports) of Suriname in 1994 to that in 1998?
Provide a succinct answer. 0.4. What is the ratio of the Exports(as % of merchandise exports) in Denmark in 1994 to that in 2000?
Ensure brevity in your answer.  0.36. What is the ratio of the Exports(as % of merchandise exports) of Indonesia in 1994 to that in 2000?
Give a very brief answer. 1.04. What is the ratio of the Exports(as % of merchandise exports) of New Zealand in 1994 to that in 2000?
Your answer should be very brief. 0.7. What is the ratio of the Exports(as % of merchandise exports) of Suriname in 1994 to that in 2000?
Your answer should be compact. 3.39. What is the ratio of the Exports(as % of merchandise exports) in Denmark in 1994 to that in 2001?
Your answer should be compact. 0.44. What is the ratio of the Exports(as % of merchandise exports) in Indonesia in 1994 to that in 2001?
Keep it short and to the point. 1.03. What is the ratio of the Exports(as % of merchandise exports) in New Zealand in 1994 to that in 2001?
Your answer should be compact. 0.78. What is the ratio of the Exports(as % of merchandise exports) in Suriname in 1994 to that in 2001?
Your response must be concise. 2.22. What is the ratio of the Exports(as % of merchandise exports) of Denmark in 1995 to that in 1996?
Your answer should be very brief. 0.6. What is the ratio of the Exports(as % of merchandise exports) in Indonesia in 1995 to that in 1996?
Provide a succinct answer. 0.98. What is the ratio of the Exports(as % of merchandise exports) in New Zealand in 1995 to that in 1996?
Provide a short and direct response. 0.71. What is the ratio of the Exports(as % of merchandise exports) of Suriname in 1995 to that in 1996?
Provide a succinct answer. 0.68. What is the ratio of the Exports(as % of merchandise exports) in Denmark in 1995 to that in 1997?
Make the answer very short. 0.69. What is the ratio of the Exports(as % of merchandise exports) of Indonesia in 1995 to that in 1997?
Your answer should be compact. 1.03. What is the ratio of the Exports(as % of merchandise exports) in New Zealand in 1995 to that in 1997?
Offer a very short reply. 0.76. What is the ratio of the Exports(as % of merchandise exports) in Suriname in 1995 to that in 1997?
Make the answer very short. 0.47. What is the ratio of the Exports(as % of merchandise exports) in Denmark in 1995 to that in 1998?
Ensure brevity in your answer.  0.94. What is the ratio of the Exports(as % of merchandise exports) in Indonesia in 1995 to that in 1998?
Your answer should be very brief. 1.33. What is the ratio of the Exports(as % of merchandise exports) of New Zealand in 1995 to that in 1998?
Your answer should be compact. 0.79. What is the ratio of the Exports(as % of merchandise exports) of Suriname in 1995 to that in 1998?
Your answer should be very brief. 0.52. What is the ratio of the Exports(as % of merchandise exports) of Denmark in 1995 to that in 2000?
Offer a very short reply. 0.37. What is the ratio of the Exports(as % of merchandise exports) in New Zealand in 1995 to that in 2000?
Offer a very short reply. 0.55. What is the ratio of the Exports(as % of merchandise exports) of Suriname in 1995 to that in 2000?
Your answer should be very brief. 4.37. What is the ratio of the Exports(as % of merchandise exports) of Denmark in 1995 to that in 2001?
Offer a terse response. 0.45. What is the ratio of the Exports(as % of merchandise exports) of Indonesia in 1995 to that in 2001?
Your answer should be compact. 0.99. What is the ratio of the Exports(as % of merchandise exports) of New Zealand in 1995 to that in 2001?
Give a very brief answer. 0.61. What is the ratio of the Exports(as % of merchandise exports) in Suriname in 1995 to that in 2001?
Offer a terse response. 2.86. What is the ratio of the Exports(as % of merchandise exports) of Denmark in 1996 to that in 1997?
Make the answer very short. 1.14. What is the ratio of the Exports(as % of merchandise exports) of Indonesia in 1996 to that in 1997?
Offer a terse response. 1.05. What is the ratio of the Exports(as % of merchandise exports) of New Zealand in 1996 to that in 1997?
Your response must be concise. 1.08. What is the ratio of the Exports(as % of merchandise exports) of Suriname in 1996 to that in 1997?
Make the answer very short. 0.68. What is the ratio of the Exports(as % of merchandise exports) in Denmark in 1996 to that in 1998?
Give a very brief answer. 1.56. What is the ratio of the Exports(as % of merchandise exports) in Indonesia in 1996 to that in 1998?
Offer a very short reply. 1.35. What is the ratio of the Exports(as % of merchandise exports) in New Zealand in 1996 to that in 1998?
Your response must be concise. 1.12. What is the ratio of the Exports(as % of merchandise exports) in Suriname in 1996 to that in 1998?
Offer a terse response. 0.76. What is the ratio of the Exports(as % of merchandise exports) in Denmark in 1996 to that in 2000?
Give a very brief answer. 0.61. What is the ratio of the Exports(as % of merchandise exports) of Indonesia in 1996 to that in 2000?
Give a very brief answer. 1.02. What is the ratio of the Exports(as % of merchandise exports) in New Zealand in 1996 to that in 2000?
Offer a terse response. 0.78. What is the ratio of the Exports(as % of merchandise exports) of Suriname in 1996 to that in 2000?
Your response must be concise. 6.4. What is the ratio of the Exports(as % of merchandise exports) in Denmark in 1996 to that in 2001?
Provide a succinct answer. 0.75. What is the ratio of the Exports(as % of merchandise exports) of Indonesia in 1996 to that in 2001?
Offer a very short reply. 1.01. What is the ratio of the Exports(as % of merchandise exports) in New Zealand in 1996 to that in 2001?
Your response must be concise. 0.87. What is the ratio of the Exports(as % of merchandise exports) of Suriname in 1996 to that in 2001?
Provide a short and direct response. 4.19. What is the ratio of the Exports(as % of merchandise exports) of Denmark in 1997 to that in 1998?
Ensure brevity in your answer.  1.36. What is the ratio of the Exports(as % of merchandise exports) in Indonesia in 1997 to that in 1998?
Offer a terse response. 1.29. What is the ratio of the Exports(as % of merchandise exports) in New Zealand in 1997 to that in 1998?
Provide a short and direct response. 1.04. What is the ratio of the Exports(as % of merchandise exports) in Suriname in 1997 to that in 1998?
Your answer should be very brief. 1.11. What is the ratio of the Exports(as % of merchandise exports) in Denmark in 1997 to that in 2000?
Ensure brevity in your answer.  0.54. What is the ratio of the Exports(as % of merchandise exports) in Indonesia in 1997 to that in 2000?
Your answer should be very brief. 0.97. What is the ratio of the Exports(as % of merchandise exports) in New Zealand in 1997 to that in 2000?
Provide a succinct answer. 0.72. What is the ratio of the Exports(as % of merchandise exports) in Suriname in 1997 to that in 2000?
Your answer should be compact. 9.37. What is the ratio of the Exports(as % of merchandise exports) in Denmark in 1997 to that in 2001?
Your answer should be compact. 0.66. What is the ratio of the Exports(as % of merchandise exports) of Indonesia in 1997 to that in 2001?
Make the answer very short. 0.97. What is the ratio of the Exports(as % of merchandise exports) of New Zealand in 1997 to that in 2001?
Provide a succinct answer. 0.8. What is the ratio of the Exports(as % of merchandise exports) of Suriname in 1997 to that in 2001?
Provide a short and direct response. 6.13. What is the ratio of the Exports(as % of merchandise exports) in Denmark in 1998 to that in 2000?
Your answer should be very brief. 0.39. What is the ratio of the Exports(as % of merchandise exports) in Indonesia in 1998 to that in 2000?
Ensure brevity in your answer.  0.75. What is the ratio of the Exports(as % of merchandise exports) in New Zealand in 1998 to that in 2000?
Ensure brevity in your answer.  0.69. What is the ratio of the Exports(as % of merchandise exports) in Suriname in 1998 to that in 2000?
Your answer should be very brief. 8.45. What is the ratio of the Exports(as % of merchandise exports) in Denmark in 1998 to that in 2001?
Give a very brief answer. 0.48. What is the ratio of the Exports(as % of merchandise exports) in Indonesia in 1998 to that in 2001?
Provide a succinct answer. 0.75. What is the ratio of the Exports(as % of merchandise exports) of New Zealand in 1998 to that in 2001?
Your response must be concise. 0.77. What is the ratio of the Exports(as % of merchandise exports) in Suriname in 1998 to that in 2001?
Give a very brief answer. 5.53. What is the ratio of the Exports(as % of merchandise exports) of Denmark in 2000 to that in 2001?
Your answer should be very brief. 1.22. What is the ratio of the Exports(as % of merchandise exports) of Indonesia in 2000 to that in 2001?
Keep it short and to the point. 0.99. What is the ratio of the Exports(as % of merchandise exports) of New Zealand in 2000 to that in 2001?
Keep it short and to the point. 1.11. What is the ratio of the Exports(as % of merchandise exports) of Suriname in 2000 to that in 2001?
Your answer should be compact. 0.65. What is the difference between the highest and the second highest Exports(as % of merchandise exports) in Denmark?
Ensure brevity in your answer.  1.28. What is the difference between the highest and the second highest Exports(as % of merchandise exports) in Indonesia?
Make the answer very short. 0.54. What is the difference between the highest and the second highest Exports(as % of merchandise exports) of New Zealand?
Offer a very short reply. 0.3. What is the difference between the highest and the second highest Exports(as % of merchandise exports) of Suriname?
Make the answer very short. 0.49. What is the difference between the highest and the lowest Exports(as % of merchandise exports) of Denmark?
Your response must be concise. 4.51. What is the difference between the highest and the lowest Exports(as % of merchandise exports) in Indonesia?
Ensure brevity in your answer.  7.31. What is the difference between the highest and the lowest Exports(as % of merchandise exports) in New Zealand?
Offer a very short reply. 1.35. What is the difference between the highest and the lowest Exports(as % of merchandise exports) in Suriname?
Provide a short and direct response. 4.42. 